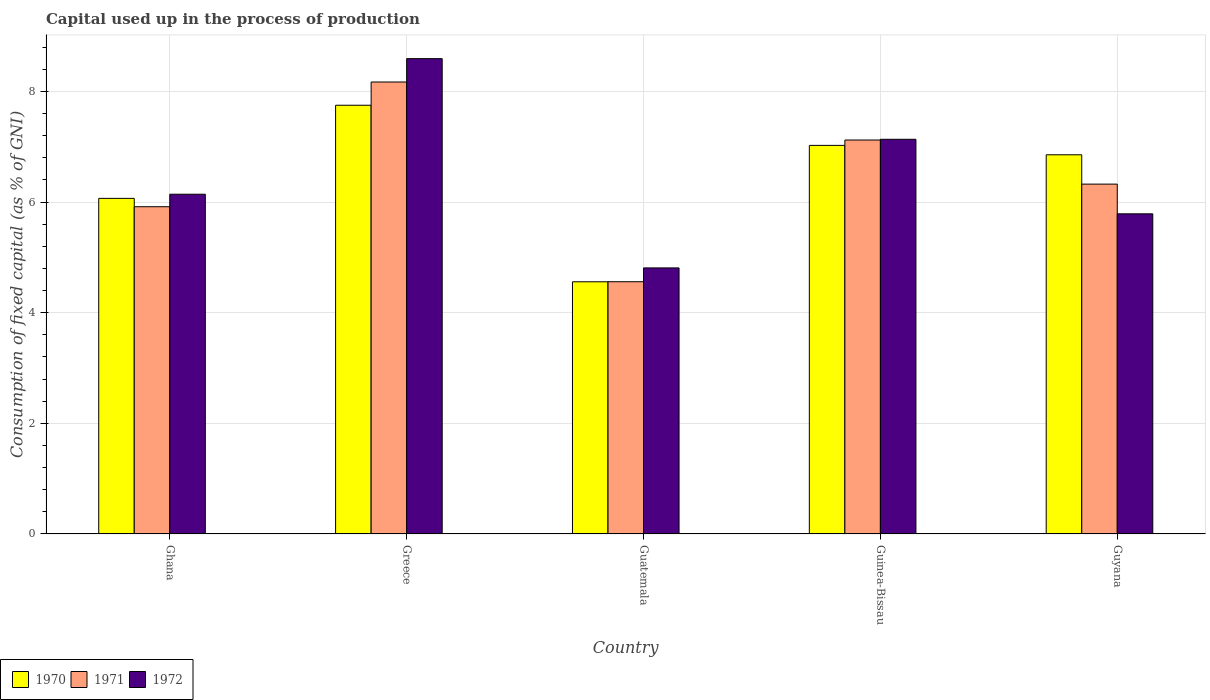How many groups of bars are there?
Your response must be concise. 5. Are the number of bars per tick equal to the number of legend labels?
Keep it short and to the point. Yes. Are the number of bars on each tick of the X-axis equal?
Keep it short and to the point. Yes. How many bars are there on the 1st tick from the left?
Keep it short and to the point. 3. In how many cases, is the number of bars for a given country not equal to the number of legend labels?
Offer a terse response. 0. What is the capital used up in the process of production in 1972 in Ghana?
Offer a very short reply. 6.14. Across all countries, what is the maximum capital used up in the process of production in 1970?
Make the answer very short. 7.75. Across all countries, what is the minimum capital used up in the process of production in 1972?
Your answer should be compact. 4.81. In which country was the capital used up in the process of production in 1972 minimum?
Provide a succinct answer. Guatemala. What is the total capital used up in the process of production in 1971 in the graph?
Your response must be concise. 32.09. What is the difference between the capital used up in the process of production in 1971 in Ghana and that in Guatemala?
Give a very brief answer. 1.36. What is the difference between the capital used up in the process of production in 1972 in Guinea-Bissau and the capital used up in the process of production in 1971 in Guatemala?
Provide a succinct answer. 2.57. What is the average capital used up in the process of production in 1970 per country?
Provide a short and direct response. 6.45. What is the difference between the capital used up in the process of production of/in 1970 and capital used up in the process of production of/in 1971 in Guyana?
Your response must be concise. 0.53. What is the ratio of the capital used up in the process of production in 1972 in Ghana to that in Greece?
Keep it short and to the point. 0.71. Is the capital used up in the process of production in 1972 in Ghana less than that in Greece?
Ensure brevity in your answer.  Yes. What is the difference between the highest and the second highest capital used up in the process of production in 1972?
Provide a short and direct response. 2.45. What is the difference between the highest and the lowest capital used up in the process of production in 1971?
Give a very brief answer. 3.61. Is the sum of the capital used up in the process of production in 1972 in Ghana and Greece greater than the maximum capital used up in the process of production in 1971 across all countries?
Your response must be concise. Yes. What does the 2nd bar from the left in Greece represents?
Offer a very short reply. 1971. Is it the case that in every country, the sum of the capital used up in the process of production in 1972 and capital used up in the process of production in 1971 is greater than the capital used up in the process of production in 1970?
Provide a succinct answer. Yes. Are all the bars in the graph horizontal?
Your answer should be compact. No. What is the difference between two consecutive major ticks on the Y-axis?
Keep it short and to the point. 2. Does the graph contain any zero values?
Offer a terse response. No. Does the graph contain grids?
Your answer should be compact. Yes. What is the title of the graph?
Provide a succinct answer. Capital used up in the process of production. What is the label or title of the X-axis?
Provide a succinct answer. Country. What is the label or title of the Y-axis?
Provide a succinct answer. Consumption of fixed capital (as % of GNI). What is the Consumption of fixed capital (as % of GNI) of 1970 in Ghana?
Offer a terse response. 6.07. What is the Consumption of fixed capital (as % of GNI) in 1971 in Ghana?
Your answer should be compact. 5.92. What is the Consumption of fixed capital (as % of GNI) in 1972 in Ghana?
Give a very brief answer. 6.14. What is the Consumption of fixed capital (as % of GNI) of 1970 in Greece?
Offer a terse response. 7.75. What is the Consumption of fixed capital (as % of GNI) of 1971 in Greece?
Your response must be concise. 8.17. What is the Consumption of fixed capital (as % of GNI) in 1972 in Greece?
Provide a short and direct response. 8.59. What is the Consumption of fixed capital (as % of GNI) in 1970 in Guatemala?
Keep it short and to the point. 4.56. What is the Consumption of fixed capital (as % of GNI) of 1971 in Guatemala?
Offer a very short reply. 4.56. What is the Consumption of fixed capital (as % of GNI) in 1972 in Guatemala?
Ensure brevity in your answer.  4.81. What is the Consumption of fixed capital (as % of GNI) of 1970 in Guinea-Bissau?
Make the answer very short. 7.02. What is the Consumption of fixed capital (as % of GNI) in 1971 in Guinea-Bissau?
Provide a succinct answer. 7.12. What is the Consumption of fixed capital (as % of GNI) of 1972 in Guinea-Bissau?
Ensure brevity in your answer.  7.13. What is the Consumption of fixed capital (as % of GNI) in 1970 in Guyana?
Your answer should be compact. 6.85. What is the Consumption of fixed capital (as % of GNI) of 1971 in Guyana?
Ensure brevity in your answer.  6.32. What is the Consumption of fixed capital (as % of GNI) of 1972 in Guyana?
Provide a short and direct response. 5.79. Across all countries, what is the maximum Consumption of fixed capital (as % of GNI) of 1970?
Your answer should be very brief. 7.75. Across all countries, what is the maximum Consumption of fixed capital (as % of GNI) in 1971?
Ensure brevity in your answer.  8.17. Across all countries, what is the maximum Consumption of fixed capital (as % of GNI) of 1972?
Give a very brief answer. 8.59. Across all countries, what is the minimum Consumption of fixed capital (as % of GNI) of 1970?
Ensure brevity in your answer.  4.56. Across all countries, what is the minimum Consumption of fixed capital (as % of GNI) in 1971?
Your answer should be compact. 4.56. Across all countries, what is the minimum Consumption of fixed capital (as % of GNI) in 1972?
Offer a terse response. 4.81. What is the total Consumption of fixed capital (as % of GNI) in 1970 in the graph?
Give a very brief answer. 32.26. What is the total Consumption of fixed capital (as % of GNI) in 1971 in the graph?
Your answer should be compact. 32.09. What is the total Consumption of fixed capital (as % of GNI) in 1972 in the graph?
Keep it short and to the point. 32.47. What is the difference between the Consumption of fixed capital (as % of GNI) in 1970 in Ghana and that in Greece?
Provide a succinct answer. -1.68. What is the difference between the Consumption of fixed capital (as % of GNI) in 1971 in Ghana and that in Greece?
Keep it short and to the point. -2.25. What is the difference between the Consumption of fixed capital (as % of GNI) of 1972 in Ghana and that in Greece?
Your answer should be very brief. -2.45. What is the difference between the Consumption of fixed capital (as % of GNI) in 1970 in Ghana and that in Guatemala?
Your answer should be compact. 1.51. What is the difference between the Consumption of fixed capital (as % of GNI) of 1971 in Ghana and that in Guatemala?
Offer a very short reply. 1.36. What is the difference between the Consumption of fixed capital (as % of GNI) of 1972 in Ghana and that in Guatemala?
Provide a short and direct response. 1.33. What is the difference between the Consumption of fixed capital (as % of GNI) in 1970 in Ghana and that in Guinea-Bissau?
Provide a short and direct response. -0.96. What is the difference between the Consumption of fixed capital (as % of GNI) of 1971 in Ghana and that in Guinea-Bissau?
Provide a short and direct response. -1.21. What is the difference between the Consumption of fixed capital (as % of GNI) of 1972 in Ghana and that in Guinea-Bissau?
Offer a terse response. -0.99. What is the difference between the Consumption of fixed capital (as % of GNI) of 1970 in Ghana and that in Guyana?
Provide a short and direct response. -0.79. What is the difference between the Consumption of fixed capital (as % of GNI) of 1971 in Ghana and that in Guyana?
Your answer should be very brief. -0.41. What is the difference between the Consumption of fixed capital (as % of GNI) of 1972 in Ghana and that in Guyana?
Make the answer very short. 0.35. What is the difference between the Consumption of fixed capital (as % of GNI) of 1970 in Greece and that in Guatemala?
Ensure brevity in your answer.  3.19. What is the difference between the Consumption of fixed capital (as % of GNI) in 1971 in Greece and that in Guatemala?
Your answer should be very brief. 3.61. What is the difference between the Consumption of fixed capital (as % of GNI) in 1972 in Greece and that in Guatemala?
Provide a short and direct response. 3.78. What is the difference between the Consumption of fixed capital (as % of GNI) in 1970 in Greece and that in Guinea-Bissau?
Give a very brief answer. 0.73. What is the difference between the Consumption of fixed capital (as % of GNI) of 1971 in Greece and that in Guinea-Bissau?
Provide a succinct answer. 1.05. What is the difference between the Consumption of fixed capital (as % of GNI) in 1972 in Greece and that in Guinea-Bissau?
Offer a terse response. 1.46. What is the difference between the Consumption of fixed capital (as % of GNI) in 1970 in Greece and that in Guyana?
Offer a terse response. 0.9. What is the difference between the Consumption of fixed capital (as % of GNI) of 1971 in Greece and that in Guyana?
Provide a succinct answer. 1.85. What is the difference between the Consumption of fixed capital (as % of GNI) of 1972 in Greece and that in Guyana?
Make the answer very short. 2.81. What is the difference between the Consumption of fixed capital (as % of GNI) in 1970 in Guatemala and that in Guinea-Bissau?
Your response must be concise. -2.47. What is the difference between the Consumption of fixed capital (as % of GNI) of 1971 in Guatemala and that in Guinea-Bissau?
Make the answer very short. -2.56. What is the difference between the Consumption of fixed capital (as % of GNI) of 1972 in Guatemala and that in Guinea-Bissau?
Give a very brief answer. -2.33. What is the difference between the Consumption of fixed capital (as % of GNI) of 1970 in Guatemala and that in Guyana?
Your response must be concise. -2.3. What is the difference between the Consumption of fixed capital (as % of GNI) in 1971 in Guatemala and that in Guyana?
Keep it short and to the point. -1.76. What is the difference between the Consumption of fixed capital (as % of GNI) of 1972 in Guatemala and that in Guyana?
Keep it short and to the point. -0.98. What is the difference between the Consumption of fixed capital (as % of GNI) in 1970 in Guinea-Bissau and that in Guyana?
Ensure brevity in your answer.  0.17. What is the difference between the Consumption of fixed capital (as % of GNI) of 1971 in Guinea-Bissau and that in Guyana?
Your response must be concise. 0.8. What is the difference between the Consumption of fixed capital (as % of GNI) of 1972 in Guinea-Bissau and that in Guyana?
Keep it short and to the point. 1.35. What is the difference between the Consumption of fixed capital (as % of GNI) in 1970 in Ghana and the Consumption of fixed capital (as % of GNI) in 1971 in Greece?
Offer a very short reply. -2.1. What is the difference between the Consumption of fixed capital (as % of GNI) of 1970 in Ghana and the Consumption of fixed capital (as % of GNI) of 1972 in Greece?
Offer a very short reply. -2.53. What is the difference between the Consumption of fixed capital (as % of GNI) of 1971 in Ghana and the Consumption of fixed capital (as % of GNI) of 1972 in Greece?
Your answer should be very brief. -2.68. What is the difference between the Consumption of fixed capital (as % of GNI) in 1970 in Ghana and the Consumption of fixed capital (as % of GNI) in 1971 in Guatemala?
Offer a terse response. 1.51. What is the difference between the Consumption of fixed capital (as % of GNI) in 1970 in Ghana and the Consumption of fixed capital (as % of GNI) in 1972 in Guatemala?
Offer a terse response. 1.26. What is the difference between the Consumption of fixed capital (as % of GNI) in 1971 in Ghana and the Consumption of fixed capital (as % of GNI) in 1972 in Guatemala?
Give a very brief answer. 1.11. What is the difference between the Consumption of fixed capital (as % of GNI) in 1970 in Ghana and the Consumption of fixed capital (as % of GNI) in 1971 in Guinea-Bissau?
Your answer should be very brief. -1.05. What is the difference between the Consumption of fixed capital (as % of GNI) in 1970 in Ghana and the Consumption of fixed capital (as % of GNI) in 1972 in Guinea-Bissau?
Offer a terse response. -1.07. What is the difference between the Consumption of fixed capital (as % of GNI) in 1971 in Ghana and the Consumption of fixed capital (as % of GNI) in 1972 in Guinea-Bissau?
Make the answer very short. -1.22. What is the difference between the Consumption of fixed capital (as % of GNI) in 1970 in Ghana and the Consumption of fixed capital (as % of GNI) in 1971 in Guyana?
Give a very brief answer. -0.26. What is the difference between the Consumption of fixed capital (as % of GNI) in 1970 in Ghana and the Consumption of fixed capital (as % of GNI) in 1972 in Guyana?
Your answer should be very brief. 0.28. What is the difference between the Consumption of fixed capital (as % of GNI) in 1971 in Ghana and the Consumption of fixed capital (as % of GNI) in 1972 in Guyana?
Keep it short and to the point. 0.13. What is the difference between the Consumption of fixed capital (as % of GNI) in 1970 in Greece and the Consumption of fixed capital (as % of GNI) in 1971 in Guatemala?
Ensure brevity in your answer.  3.19. What is the difference between the Consumption of fixed capital (as % of GNI) of 1970 in Greece and the Consumption of fixed capital (as % of GNI) of 1972 in Guatemala?
Keep it short and to the point. 2.94. What is the difference between the Consumption of fixed capital (as % of GNI) of 1971 in Greece and the Consumption of fixed capital (as % of GNI) of 1972 in Guatemala?
Provide a succinct answer. 3.36. What is the difference between the Consumption of fixed capital (as % of GNI) in 1970 in Greece and the Consumption of fixed capital (as % of GNI) in 1971 in Guinea-Bissau?
Provide a succinct answer. 0.63. What is the difference between the Consumption of fixed capital (as % of GNI) in 1970 in Greece and the Consumption of fixed capital (as % of GNI) in 1972 in Guinea-Bissau?
Offer a very short reply. 0.62. What is the difference between the Consumption of fixed capital (as % of GNI) of 1971 in Greece and the Consumption of fixed capital (as % of GNI) of 1972 in Guinea-Bissau?
Your answer should be compact. 1.04. What is the difference between the Consumption of fixed capital (as % of GNI) of 1970 in Greece and the Consumption of fixed capital (as % of GNI) of 1971 in Guyana?
Offer a very short reply. 1.43. What is the difference between the Consumption of fixed capital (as % of GNI) in 1970 in Greece and the Consumption of fixed capital (as % of GNI) in 1972 in Guyana?
Your answer should be compact. 1.96. What is the difference between the Consumption of fixed capital (as % of GNI) of 1971 in Greece and the Consumption of fixed capital (as % of GNI) of 1972 in Guyana?
Give a very brief answer. 2.38. What is the difference between the Consumption of fixed capital (as % of GNI) of 1970 in Guatemala and the Consumption of fixed capital (as % of GNI) of 1971 in Guinea-Bissau?
Give a very brief answer. -2.56. What is the difference between the Consumption of fixed capital (as % of GNI) of 1970 in Guatemala and the Consumption of fixed capital (as % of GNI) of 1972 in Guinea-Bissau?
Ensure brevity in your answer.  -2.58. What is the difference between the Consumption of fixed capital (as % of GNI) of 1971 in Guatemala and the Consumption of fixed capital (as % of GNI) of 1972 in Guinea-Bissau?
Your answer should be very brief. -2.57. What is the difference between the Consumption of fixed capital (as % of GNI) in 1970 in Guatemala and the Consumption of fixed capital (as % of GNI) in 1971 in Guyana?
Offer a terse response. -1.77. What is the difference between the Consumption of fixed capital (as % of GNI) of 1970 in Guatemala and the Consumption of fixed capital (as % of GNI) of 1972 in Guyana?
Ensure brevity in your answer.  -1.23. What is the difference between the Consumption of fixed capital (as % of GNI) of 1971 in Guatemala and the Consumption of fixed capital (as % of GNI) of 1972 in Guyana?
Make the answer very short. -1.23. What is the difference between the Consumption of fixed capital (as % of GNI) in 1970 in Guinea-Bissau and the Consumption of fixed capital (as % of GNI) in 1971 in Guyana?
Give a very brief answer. 0.7. What is the difference between the Consumption of fixed capital (as % of GNI) of 1970 in Guinea-Bissau and the Consumption of fixed capital (as % of GNI) of 1972 in Guyana?
Ensure brevity in your answer.  1.24. What is the difference between the Consumption of fixed capital (as % of GNI) in 1971 in Guinea-Bissau and the Consumption of fixed capital (as % of GNI) in 1972 in Guyana?
Offer a terse response. 1.33. What is the average Consumption of fixed capital (as % of GNI) in 1970 per country?
Make the answer very short. 6.45. What is the average Consumption of fixed capital (as % of GNI) in 1971 per country?
Your answer should be very brief. 6.42. What is the average Consumption of fixed capital (as % of GNI) in 1972 per country?
Your answer should be compact. 6.49. What is the difference between the Consumption of fixed capital (as % of GNI) in 1970 and Consumption of fixed capital (as % of GNI) in 1971 in Ghana?
Offer a terse response. 0.15. What is the difference between the Consumption of fixed capital (as % of GNI) of 1970 and Consumption of fixed capital (as % of GNI) of 1972 in Ghana?
Your answer should be compact. -0.07. What is the difference between the Consumption of fixed capital (as % of GNI) of 1971 and Consumption of fixed capital (as % of GNI) of 1972 in Ghana?
Your answer should be very brief. -0.23. What is the difference between the Consumption of fixed capital (as % of GNI) of 1970 and Consumption of fixed capital (as % of GNI) of 1971 in Greece?
Give a very brief answer. -0.42. What is the difference between the Consumption of fixed capital (as % of GNI) of 1970 and Consumption of fixed capital (as % of GNI) of 1972 in Greece?
Provide a short and direct response. -0.84. What is the difference between the Consumption of fixed capital (as % of GNI) of 1971 and Consumption of fixed capital (as % of GNI) of 1972 in Greece?
Keep it short and to the point. -0.42. What is the difference between the Consumption of fixed capital (as % of GNI) of 1970 and Consumption of fixed capital (as % of GNI) of 1971 in Guatemala?
Offer a terse response. -0. What is the difference between the Consumption of fixed capital (as % of GNI) in 1970 and Consumption of fixed capital (as % of GNI) in 1972 in Guatemala?
Provide a succinct answer. -0.25. What is the difference between the Consumption of fixed capital (as % of GNI) in 1971 and Consumption of fixed capital (as % of GNI) in 1972 in Guatemala?
Ensure brevity in your answer.  -0.25. What is the difference between the Consumption of fixed capital (as % of GNI) in 1970 and Consumption of fixed capital (as % of GNI) in 1971 in Guinea-Bissau?
Provide a short and direct response. -0.1. What is the difference between the Consumption of fixed capital (as % of GNI) in 1970 and Consumption of fixed capital (as % of GNI) in 1972 in Guinea-Bissau?
Offer a very short reply. -0.11. What is the difference between the Consumption of fixed capital (as % of GNI) of 1971 and Consumption of fixed capital (as % of GNI) of 1972 in Guinea-Bissau?
Give a very brief answer. -0.01. What is the difference between the Consumption of fixed capital (as % of GNI) in 1970 and Consumption of fixed capital (as % of GNI) in 1971 in Guyana?
Provide a short and direct response. 0.53. What is the difference between the Consumption of fixed capital (as % of GNI) in 1970 and Consumption of fixed capital (as % of GNI) in 1972 in Guyana?
Your response must be concise. 1.07. What is the difference between the Consumption of fixed capital (as % of GNI) of 1971 and Consumption of fixed capital (as % of GNI) of 1972 in Guyana?
Your answer should be very brief. 0.54. What is the ratio of the Consumption of fixed capital (as % of GNI) in 1970 in Ghana to that in Greece?
Your response must be concise. 0.78. What is the ratio of the Consumption of fixed capital (as % of GNI) of 1971 in Ghana to that in Greece?
Offer a very short reply. 0.72. What is the ratio of the Consumption of fixed capital (as % of GNI) in 1972 in Ghana to that in Greece?
Your response must be concise. 0.71. What is the ratio of the Consumption of fixed capital (as % of GNI) in 1970 in Ghana to that in Guatemala?
Provide a succinct answer. 1.33. What is the ratio of the Consumption of fixed capital (as % of GNI) in 1971 in Ghana to that in Guatemala?
Offer a terse response. 1.3. What is the ratio of the Consumption of fixed capital (as % of GNI) of 1972 in Ghana to that in Guatemala?
Provide a short and direct response. 1.28. What is the ratio of the Consumption of fixed capital (as % of GNI) in 1970 in Ghana to that in Guinea-Bissau?
Ensure brevity in your answer.  0.86. What is the ratio of the Consumption of fixed capital (as % of GNI) in 1971 in Ghana to that in Guinea-Bissau?
Make the answer very short. 0.83. What is the ratio of the Consumption of fixed capital (as % of GNI) in 1972 in Ghana to that in Guinea-Bissau?
Offer a very short reply. 0.86. What is the ratio of the Consumption of fixed capital (as % of GNI) of 1970 in Ghana to that in Guyana?
Provide a short and direct response. 0.89. What is the ratio of the Consumption of fixed capital (as % of GNI) of 1971 in Ghana to that in Guyana?
Keep it short and to the point. 0.94. What is the ratio of the Consumption of fixed capital (as % of GNI) of 1972 in Ghana to that in Guyana?
Provide a succinct answer. 1.06. What is the ratio of the Consumption of fixed capital (as % of GNI) in 1970 in Greece to that in Guatemala?
Your answer should be very brief. 1.7. What is the ratio of the Consumption of fixed capital (as % of GNI) of 1971 in Greece to that in Guatemala?
Your answer should be compact. 1.79. What is the ratio of the Consumption of fixed capital (as % of GNI) of 1972 in Greece to that in Guatemala?
Offer a terse response. 1.79. What is the ratio of the Consumption of fixed capital (as % of GNI) of 1970 in Greece to that in Guinea-Bissau?
Offer a very short reply. 1.1. What is the ratio of the Consumption of fixed capital (as % of GNI) in 1971 in Greece to that in Guinea-Bissau?
Your answer should be very brief. 1.15. What is the ratio of the Consumption of fixed capital (as % of GNI) in 1972 in Greece to that in Guinea-Bissau?
Your response must be concise. 1.2. What is the ratio of the Consumption of fixed capital (as % of GNI) in 1970 in Greece to that in Guyana?
Ensure brevity in your answer.  1.13. What is the ratio of the Consumption of fixed capital (as % of GNI) of 1971 in Greece to that in Guyana?
Offer a very short reply. 1.29. What is the ratio of the Consumption of fixed capital (as % of GNI) in 1972 in Greece to that in Guyana?
Your answer should be compact. 1.48. What is the ratio of the Consumption of fixed capital (as % of GNI) in 1970 in Guatemala to that in Guinea-Bissau?
Ensure brevity in your answer.  0.65. What is the ratio of the Consumption of fixed capital (as % of GNI) of 1971 in Guatemala to that in Guinea-Bissau?
Your response must be concise. 0.64. What is the ratio of the Consumption of fixed capital (as % of GNI) in 1972 in Guatemala to that in Guinea-Bissau?
Give a very brief answer. 0.67. What is the ratio of the Consumption of fixed capital (as % of GNI) of 1970 in Guatemala to that in Guyana?
Offer a very short reply. 0.67. What is the ratio of the Consumption of fixed capital (as % of GNI) of 1971 in Guatemala to that in Guyana?
Offer a terse response. 0.72. What is the ratio of the Consumption of fixed capital (as % of GNI) in 1972 in Guatemala to that in Guyana?
Provide a short and direct response. 0.83. What is the ratio of the Consumption of fixed capital (as % of GNI) of 1970 in Guinea-Bissau to that in Guyana?
Provide a succinct answer. 1.02. What is the ratio of the Consumption of fixed capital (as % of GNI) in 1971 in Guinea-Bissau to that in Guyana?
Your answer should be compact. 1.13. What is the ratio of the Consumption of fixed capital (as % of GNI) in 1972 in Guinea-Bissau to that in Guyana?
Offer a terse response. 1.23. What is the difference between the highest and the second highest Consumption of fixed capital (as % of GNI) in 1970?
Your answer should be very brief. 0.73. What is the difference between the highest and the second highest Consumption of fixed capital (as % of GNI) in 1971?
Make the answer very short. 1.05. What is the difference between the highest and the second highest Consumption of fixed capital (as % of GNI) of 1972?
Keep it short and to the point. 1.46. What is the difference between the highest and the lowest Consumption of fixed capital (as % of GNI) in 1970?
Offer a very short reply. 3.19. What is the difference between the highest and the lowest Consumption of fixed capital (as % of GNI) in 1971?
Offer a very short reply. 3.61. What is the difference between the highest and the lowest Consumption of fixed capital (as % of GNI) of 1972?
Provide a short and direct response. 3.78. 